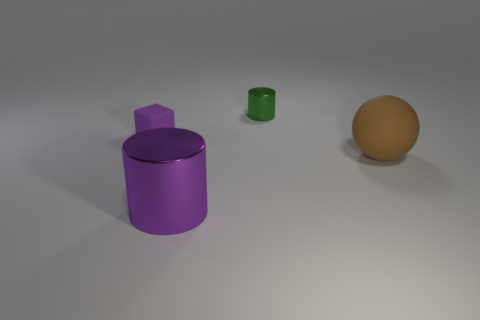Does the green thing have the same size as the purple shiny cylinder?
Your response must be concise. No. Does the purple rubber thing have the same shape as the tiny green metal object?
Give a very brief answer. No. What is the material of the other thing that is the same shape as the small shiny object?
Your answer should be very brief. Metal. There is a rubber thing left of the tiny object that is behind the tiny purple thing; how big is it?
Provide a short and direct response. Small. What is the color of the matte cube?
Ensure brevity in your answer.  Purple. There is a purple object behind the sphere; how many tiny cylinders are right of it?
Offer a very short reply. 1. Is there a cylinder to the left of the tiny thing behind the purple rubber thing?
Offer a very short reply. Yes. Are there any small rubber blocks in front of the matte sphere?
Provide a short and direct response. No. There is a metal thing that is behind the large purple cylinder; is it the same shape as the large purple object?
Your answer should be compact. Yes. What number of other brown objects have the same shape as the big brown object?
Your answer should be compact. 0. 